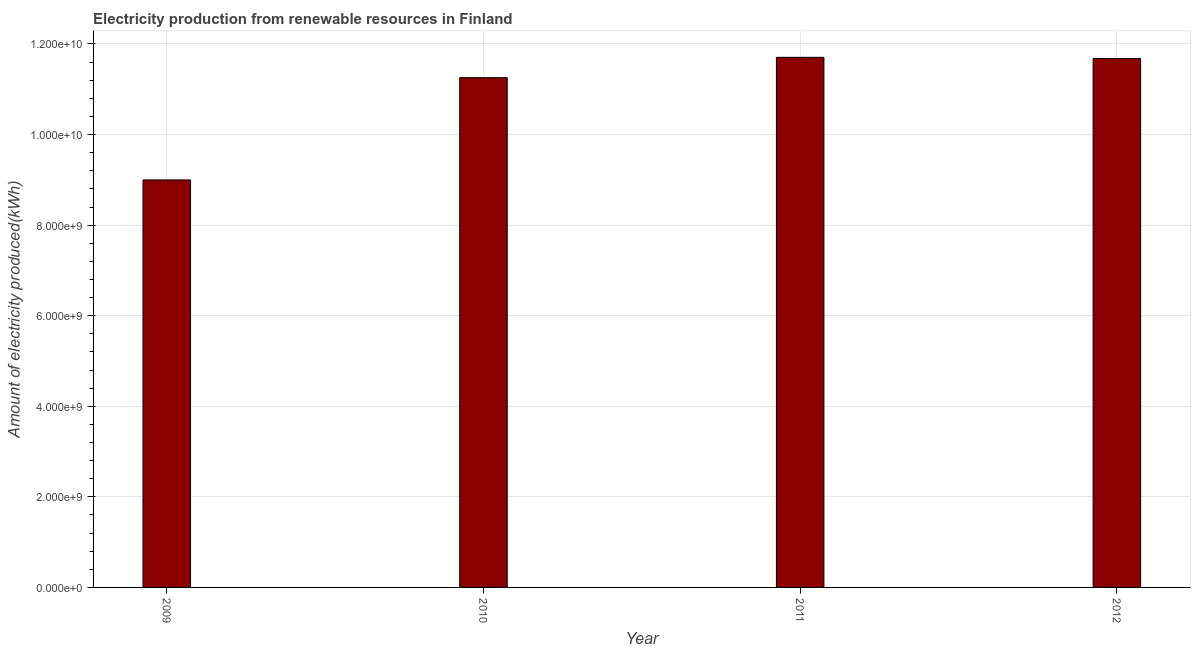Does the graph contain any zero values?
Provide a short and direct response. No. Does the graph contain grids?
Give a very brief answer. Yes. What is the title of the graph?
Your answer should be compact. Electricity production from renewable resources in Finland. What is the label or title of the X-axis?
Provide a succinct answer. Year. What is the label or title of the Y-axis?
Provide a succinct answer. Amount of electricity produced(kWh). What is the amount of electricity produced in 2010?
Provide a succinct answer. 1.13e+1. Across all years, what is the maximum amount of electricity produced?
Give a very brief answer. 1.17e+1. Across all years, what is the minimum amount of electricity produced?
Give a very brief answer. 9.00e+09. In which year was the amount of electricity produced minimum?
Ensure brevity in your answer.  2009. What is the sum of the amount of electricity produced?
Offer a terse response. 4.36e+1. What is the difference between the amount of electricity produced in 2010 and 2012?
Offer a terse response. -4.23e+08. What is the average amount of electricity produced per year?
Keep it short and to the point. 1.09e+1. What is the median amount of electricity produced?
Provide a succinct answer. 1.15e+1. Do a majority of the years between 2009 and 2011 (inclusive) have amount of electricity produced greater than 7600000000 kWh?
Your response must be concise. Yes. Is the amount of electricity produced in 2009 less than that in 2010?
Give a very brief answer. Yes. Is the difference between the amount of electricity produced in 2010 and 2012 greater than the difference between any two years?
Keep it short and to the point. No. What is the difference between the highest and the second highest amount of electricity produced?
Make the answer very short. 2.60e+07. What is the difference between the highest and the lowest amount of electricity produced?
Your answer should be very brief. 2.71e+09. In how many years, is the amount of electricity produced greater than the average amount of electricity produced taken over all years?
Your answer should be compact. 3. How many years are there in the graph?
Provide a succinct answer. 4. Are the values on the major ticks of Y-axis written in scientific E-notation?
Offer a terse response. Yes. What is the Amount of electricity produced(kWh) of 2009?
Your answer should be compact. 9.00e+09. What is the Amount of electricity produced(kWh) of 2010?
Your response must be concise. 1.13e+1. What is the Amount of electricity produced(kWh) of 2011?
Your answer should be very brief. 1.17e+1. What is the Amount of electricity produced(kWh) of 2012?
Provide a succinct answer. 1.17e+1. What is the difference between the Amount of electricity produced(kWh) in 2009 and 2010?
Your answer should be compact. -2.26e+09. What is the difference between the Amount of electricity produced(kWh) in 2009 and 2011?
Your answer should be compact. -2.71e+09. What is the difference between the Amount of electricity produced(kWh) in 2009 and 2012?
Keep it short and to the point. -2.68e+09. What is the difference between the Amount of electricity produced(kWh) in 2010 and 2011?
Your response must be concise. -4.49e+08. What is the difference between the Amount of electricity produced(kWh) in 2010 and 2012?
Offer a terse response. -4.23e+08. What is the difference between the Amount of electricity produced(kWh) in 2011 and 2012?
Your response must be concise. 2.60e+07. What is the ratio of the Amount of electricity produced(kWh) in 2009 to that in 2010?
Offer a terse response. 0.8. What is the ratio of the Amount of electricity produced(kWh) in 2009 to that in 2011?
Your response must be concise. 0.77. What is the ratio of the Amount of electricity produced(kWh) in 2009 to that in 2012?
Provide a succinct answer. 0.77. What is the ratio of the Amount of electricity produced(kWh) in 2010 to that in 2011?
Offer a very short reply. 0.96. What is the ratio of the Amount of electricity produced(kWh) in 2010 to that in 2012?
Provide a short and direct response. 0.96. 